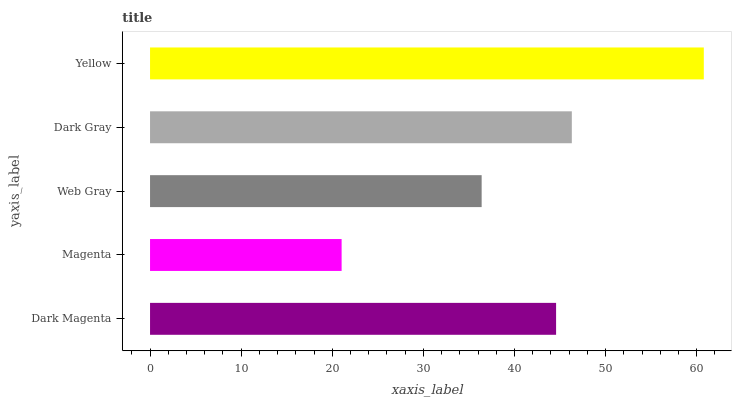Is Magenta the minimum?
Answer yes or no. Yes. Is Yellow the maximum?
Answer yes or no. Yes. Is Web Gray the minimum?
Answer yes or no. No. Is Web Gray the maximum?
Answer yes or no. No. Is Web Gray greater than Magenta?
Answer yes or no. Yes. Is Magenta less than Web Gray?
Answer yes or no. Yes. Is Magenta greater than Web Gray?
Answer yes or no. No. Is Web Gray less than Magenta?
Answer yes or no. No. Is Dark Magenta the high median?
Answer yes or no. Yes. Is Dark Magenta the low median?
Answer yes or no. Yes. Is Magenta the high median?
Answer yes or no. No. Is Dark Gray the low median?
Answer yes or no. No. 